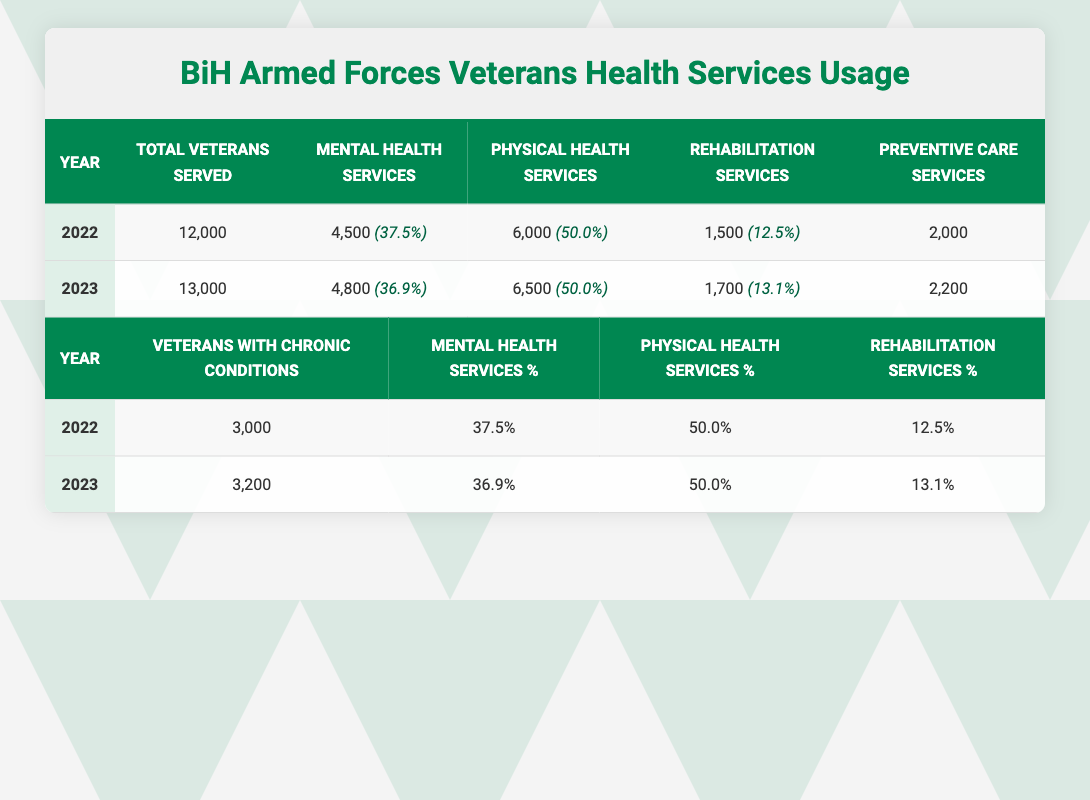What was the total number of veterans served in 2022? According to the table for 2022, the total veterans served is explicitly listed as 12,000.
Answer: 12,000 How many veterans utilized physical health services in 2023? From the 2023 data in the table, it shows that 6,500 veterans used physical health services.
Answer: 6,500 What is the percentage of veterans using mental health services in 2022? The table notes that for 2022, the mental health services usage is 4,500 out of 12,000 total veterans, which calculates to (4500/12000)*100 = 37.5%.
Answer: 37.5% Did the number of veterans with chronic conditions increase from 2022 to 2023? In the table, it shows that there were 3,000 veterans with chronic conditions in 2022 and 3,200 in 2023, indicating an increase.
Answer: Yes What is the total usage of rehabilitation services for both years combined? The table provides 1,500 for 2022 and 1,700 for 2023. Adding these together gives a total of 1,500 + 1,700 = 3,200 rehabilitation services used.
Answer: 3,200 What percentage of veterans used preventive care services in 2023? For 2023, the table indicates that 2,200 veterans used preventive care services, which is (2200/13000)*100 = approximately 16.92%. Thus, the percentage is about 16.9%.
Answer: 16.9% Was the percentage of veterans using rehabilitation services higher in 2023 compared to 2022? In 2022, the rehabilitation services percentage was 12.5%, and in 2023, it was 13.1%. Since 13.1% is greater than 12.5%, it confirms the increase.
Answer: Yes How many more veterans utilized mental health services in 2023 compared to 2022? The table states that 4,800 veterans used mental health services in 2023 and 4,500 in 2022. Subtracting gives 4,800 - 4,500 = 300 more veterans in 2023.
Answer: 300 